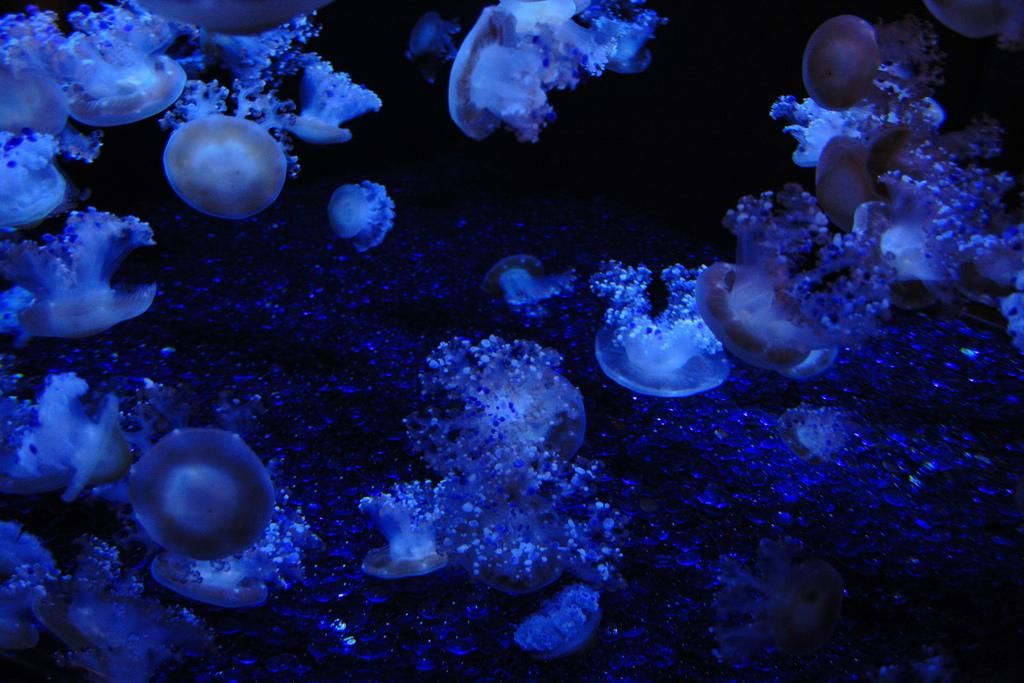What type of sea creatures are present in the image? There are jellyfishes in the image. Can you describe the appearance of the jellyfishes? The jellyfishes have a translucent, gelatinous body with long, trailing tentacles. What might be the natural habitat of these creatures? Jellyfishes are typically found in oceans and seas around the world. How many skates are visible in the image? There are no skates present in the image; it features jellyfishes. What type of clam is shown interacting with the jellyfishes in the image? There are no clams present in the image; it features jellyfishes. 